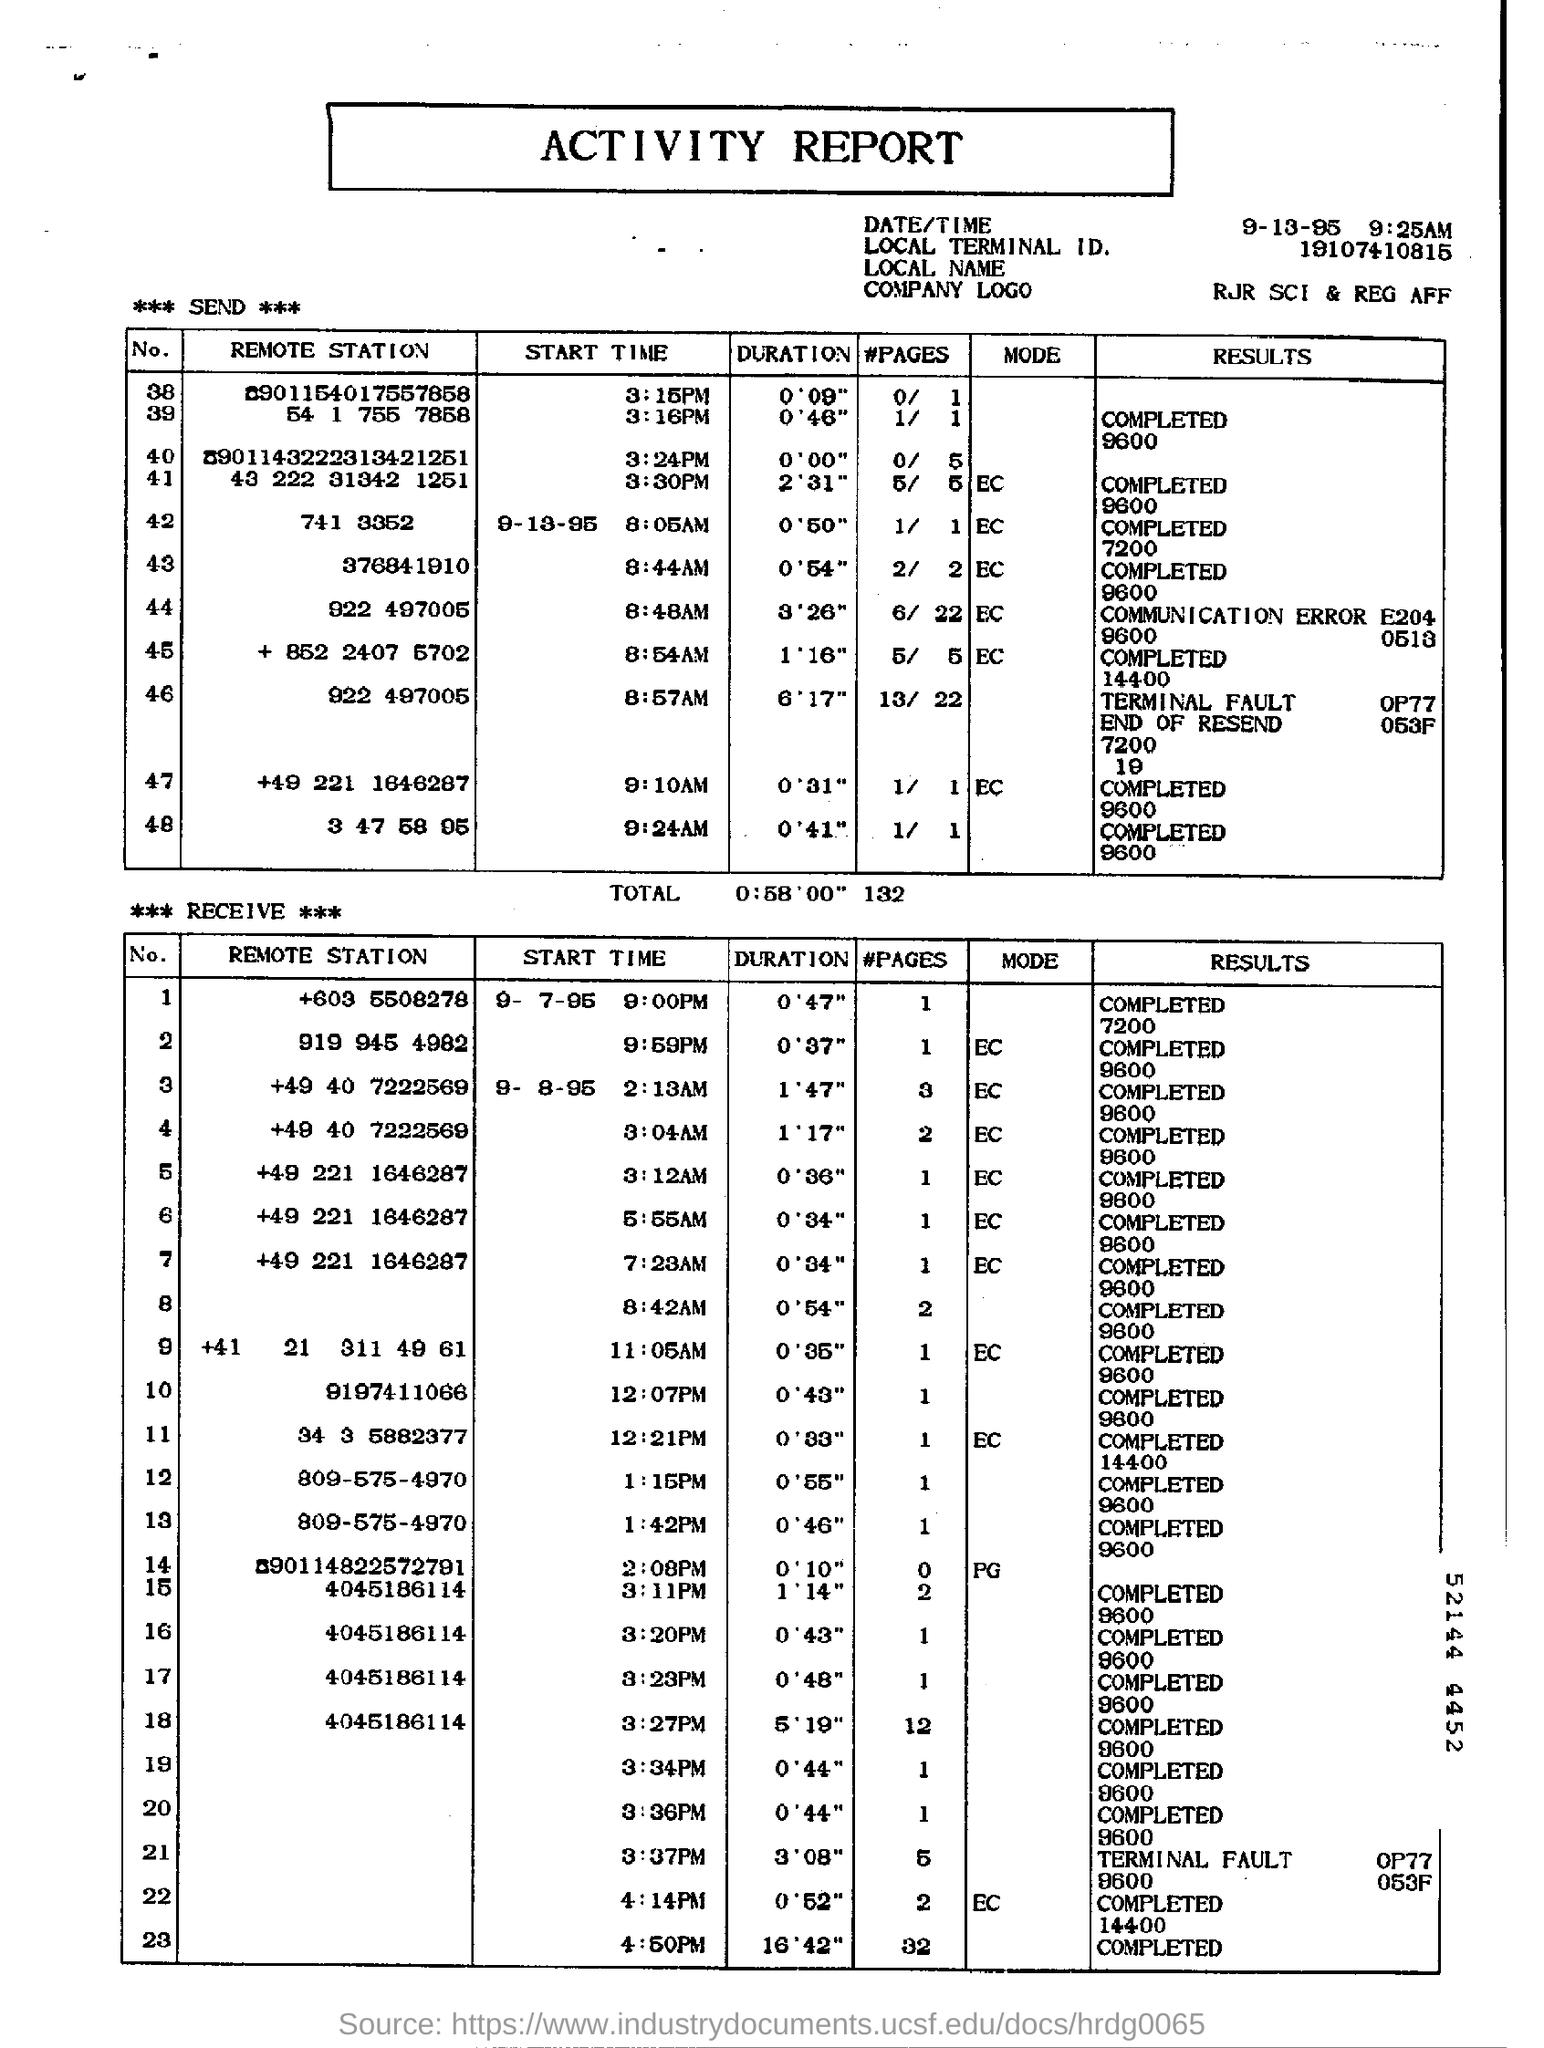Identify some key points in this picture. The Local Terminal ID mentioned in the report is 19107410815. 